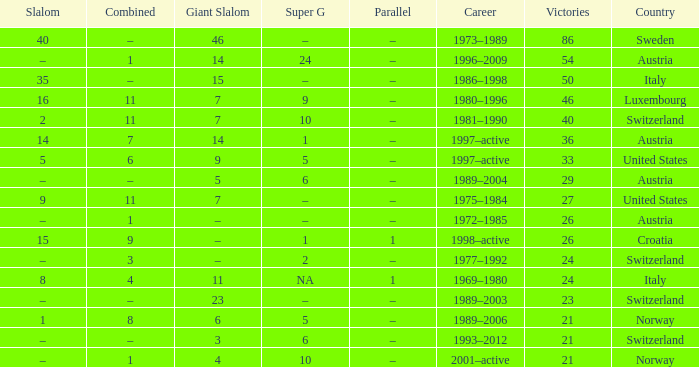What Career has a Super G of 5, and a Combined of 6? 1997–active. 